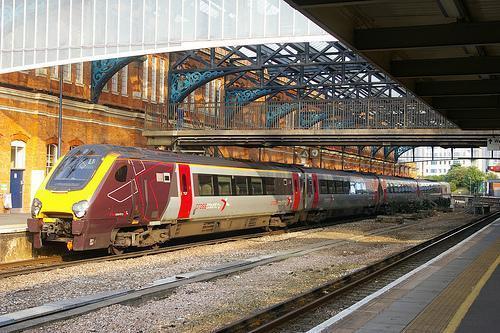How many trains are shown?
Give a very brief answer. 1. How many sets of tracks are shown?
Give a very brief answer. 2. 